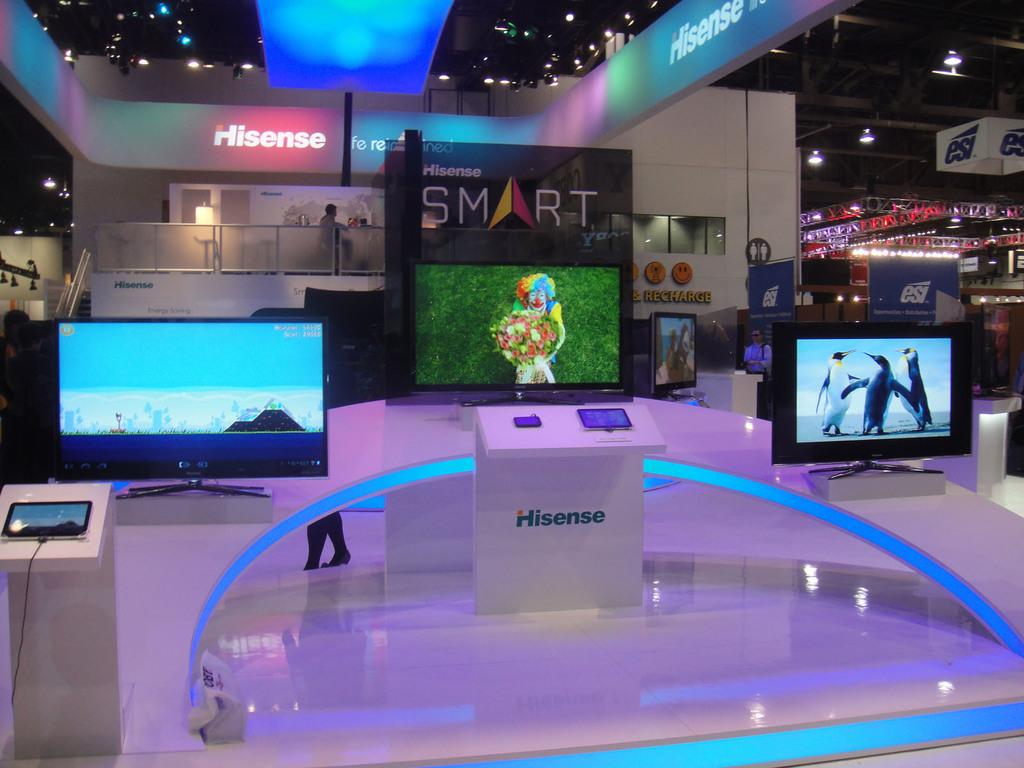<image>
Relay a brief, clear account of the picture shown. the word Smart on a sign that is in an area 